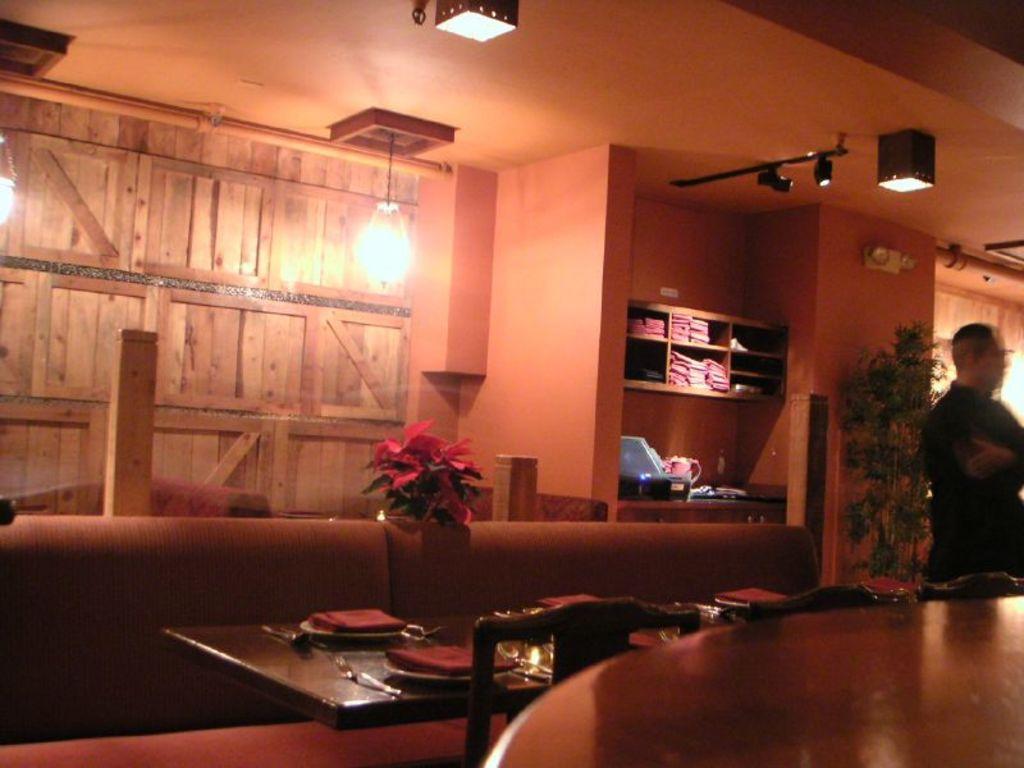Describe this image in one or two sentences. There are plates ,spoons ,glasses on a table beside the chairs. There are also lights,racks,flower vase,screen over here. On the right a person is standing in front of a plant. 